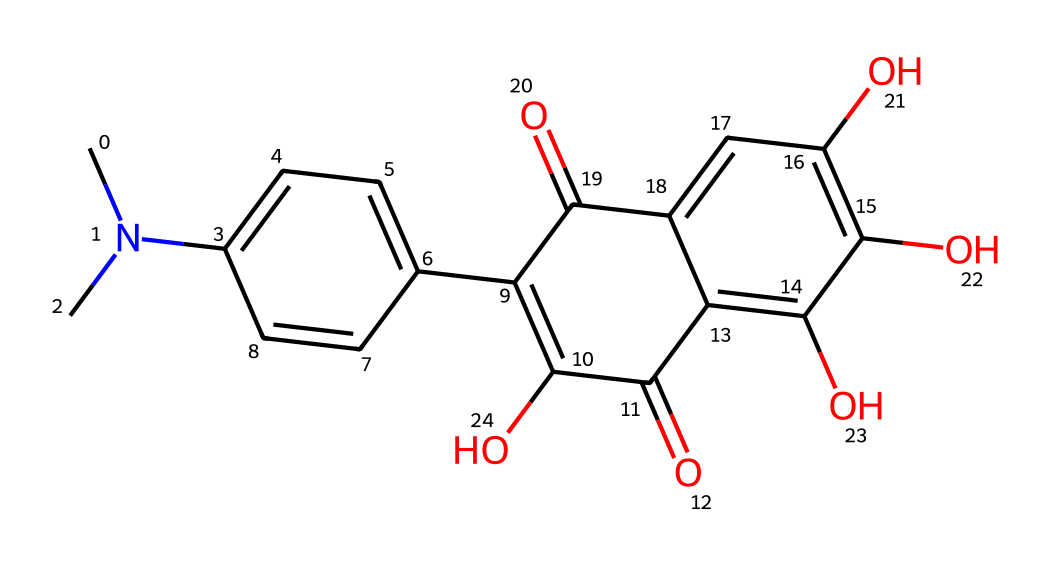What is the name of the chemical represented by this SMILES? By analyzing the provided SMILES, we can see that it contains a complex structure typical of tetracycline antibiotics. The presence of multiple aromatic rings and functional groups corresponds to tetracycline.
Answer: tetracycline How many carbon atoms are present in the structure? The SMILES can be broken down to count the carbon atom (C) symbols and connections. By analyzing the structure, counting the explicit and implied carbon atoms yields a total of 22.
Answer: 22 What type of functional groups are present in tetracycline? The SMILES shows several distinct functional groups attached to the main carbon skeleton, including hydroxyl (–OH) and ketone (C=O) groups. Identifying these groups within the structure indicates that tetracycline exhibits both alcohol and ketone functional characteristics.
Answer: hydroxyl and ketone Is this compound considered a broad-spectrum antibiotic? Tetracycline is widely known as a broad-spectrum antibiotic effective against various types of bacteria due to its ability to inhibit protein synthesis. This characteristic arises from its unique structural elements that interact with bacterial ribosomes.
Answer: yes What is the characteristic feature of tetracycline that contributes to its therapeutic efficacy? The key feature contributing to the therapeutic efficacy of tetracycline is its ability to chelate metal ions, particularly calcium, which enhances its absorption and effectiveness against bacterial pathogens. This is evident from the presence of multiple functional groups capable of forming chelation complexes.
Answer: chelation capacity What are the two main rings in the tetracycline structure? By examining the structure represented in the SMILES, we can identify the presence of two prominent aromatic rings as part of its core, which are crucial for its biological activity. These rings are referred to as the A and B rings in tetracycline.
Answer: A and B rings 